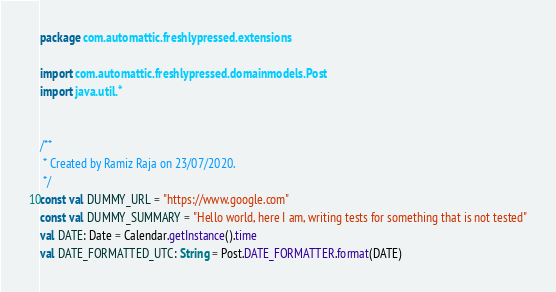Convert code to text. <code><loc_0><loc_0><loc_500><loc_500><_Kotlin_>package com.automattic.freshlypressed.extensions

import com.automattic.freshlypressed.domainmodels.Post
import java.util.*


/**
 * Created by Ramiz Raja on 23/07/2020.
 */
const val DUMMY_URL = "https://www.google.com"
const val DUMMY_SUMMARY = "Hello world, here I am, writing tests for something that is not tested"
val DATE: Date = Calendar.getInstance().time
val DATE_FORMATTED_UTC: String = Post.DATE_FORMATTER.format(DATE)</code> 